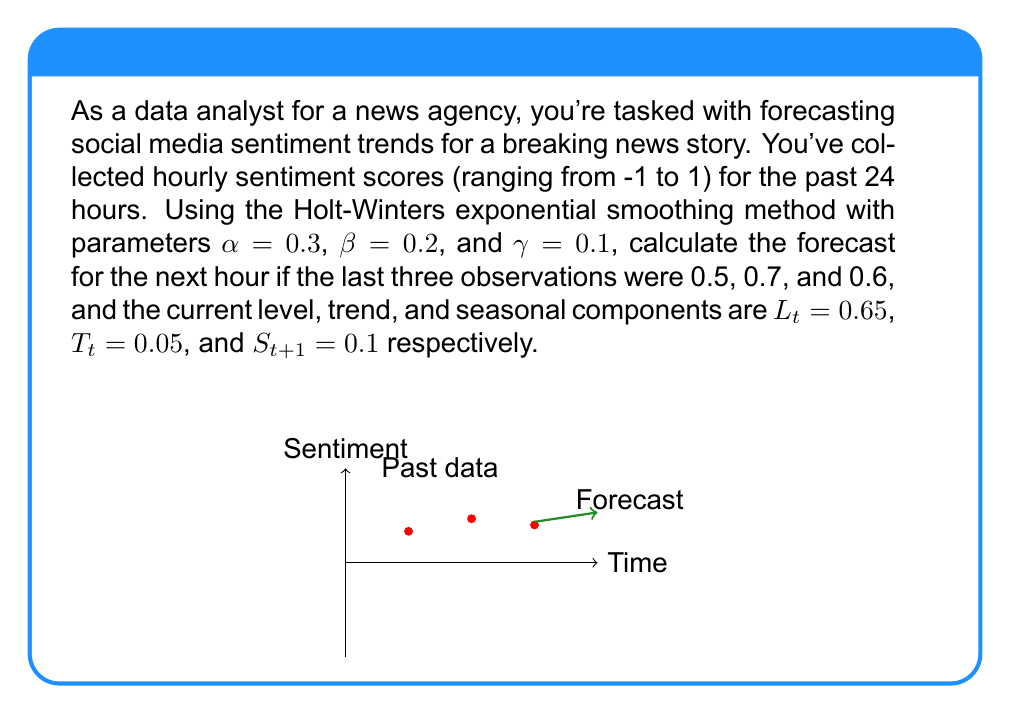Provide a solution to this math problem. To forecast the next hour's sentiment using the Holt-Winters exponential smoothing method, we need to update the level, trend, and seasonal components, then use these to make the forecast. Let's go through this step-by-step:

1) Update the level component:
   $$L_{t+1} = \alpha(Y_t - S_{t-11}) + (1-\alpha)(L_t + T_t)$$
   $$L_{t+1} = 0.3(0.6 - 0.1) + (1-0.3)(0.65 + 0.05)$$
   $$L_{t+1} = 0.3(0.5) + 0.7(0.7) = 0.15 + 0.49 = 0.64$$

2) Update the trend component:
   $$T_{t+1} = \beta(L_{t+1} - L_t) + (1-\beta)T_t$$
   $$T_{t+1} = 0.2(0.64 - 0.65) + (1-0.2)(0.05)$$
   $$T_{t+1} = 0.2(-0.01) + 0.8(0.05) = -0.002 + 0.04 = 0.038$$

3) Update the seasonal component:
   $$S_{t+1} = \gamma(Y_t - L_{t+1}) + (1-\gamma)S_{t-11}$$
   $$S_{t+1} = 0.1(0.6 - 0.64) + (1-0.1)(0.1)$$
   $$S_{t+1} = 0.1(-0.04) + 0.9(0.1) = -0.004 + 0.09 = 0.086$$

4) Calculate the forecast for the next hour:
   $$F_{t+1} = L_{t+1} + T_{t+1} + S_{t+1}$$
   $$F_{t+1} = 0.64 + 0.038 + 0.086 = 0.764$$

Thus, the forecast for the next hour's sentiment score is 0.764.
Answer: 0.764 